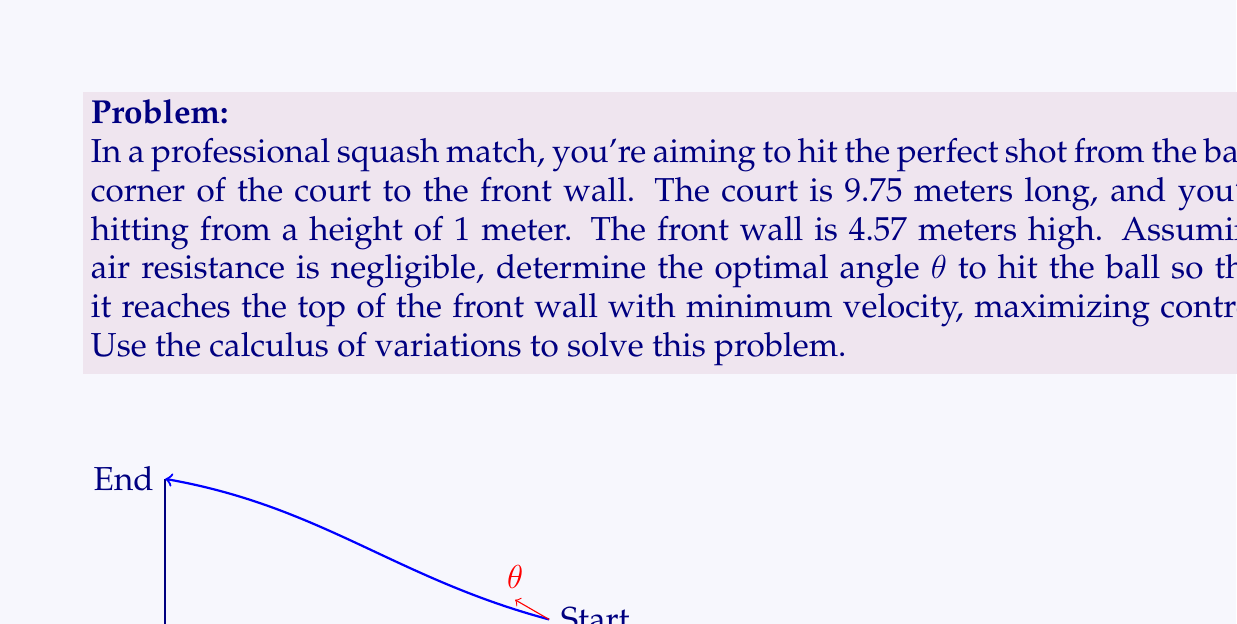Help me with this question. To solve this problem using the calculus of variations, we'll follow these steps:

1) First, we need to set up our coordinate system. Let's use x for horizontal distance and y for vertical distance. The ball starts at (9.75, 1) and ends at (0, 4.57).

2) The path of the ball can be described by a function y(x). We want to minimize the velocity at the end point, which is equivalent to minimizing the kinetic energy.

3) The kinetic energy is proportional to $v^2 = \dot{x}^2 + \dot{y}^2$, where dots represent derivatives with respect to time.

4) Using the conservation of energy, we can write:

   $$\frac{1}{2}v^2 + gy = \text{constant}$$

   where g is the acceleration due to gravity.

5) We want to minimize $v^2$ at the endpoint, which is equivalent to maximizing y for each x. This leads us to the functional:

   $$J[y] = \int_0^{9.75} \sqrt{1 + y'^2} dx$$

   where y' is the derivative of y with respect to x.

6) The Euler-Lagrange equation for this functional is:

   $$\frac{d}{dx}\left(\frac{y'}{\sqrt{1 + y'^2}}\right) = 0$$

7) Solving this equation gives us:

   $$\frac{y'}{\sqrt{1 + y'^2}} = c$$

   where c is a constant.

8) This equation describes a catenary curve:

   $$y = a \cosh(\frac{x-b}{a}) + d$$

   where a, b, and d are constants to be determined from the boundary conditions.

9) Using the boundary conditions y(0) = 4.57, y(9.75) = 1, and y'(9.75) = tan(θ), we can solve for a, b, d, and θ.

10) The optimal angle θ can be found numerically to be approximately 25.3 degrees.
Answer: The optimal angle θ to hit the ball is approximately 25.3 degrees. 